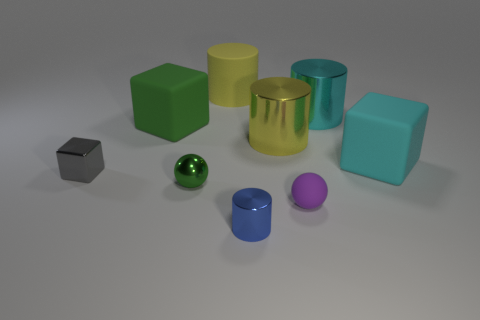There is a large matte object right of the small metal thing that is to the right of the metal sphere; what is its shape?
Provide a succinct answer. Cube. Does the tiny metallic cylinder have the same color as the small matte thing?
Your answer should be very brief. No. What number of spheres are either cyan objects or green things?
Your answer should be very brief. 1. The block that is both behind the small gray metal block and on the left side of the small blue cylinder is made of what material?
Keep it short and to the point. Rubber. How many large yellow things are behind the yellow metal cylinder?
Your answer should be compact. 1. Does the green object in front of the metal block have the same material as the yellow cylinder to the right of the yellow rubber thing?
Your answer should be compact. Yes. How many things are either big cyan things that are behind the green cube or gray metal blocks?
Offer a terse response. 2. Is the number of yellow shiny cylinders behind the cyan cylinder less than the number of cubes that are to the left of the big green thing?
Provide a short and direct response. Yes. How many other objects are the same size as the purple thing?
Give a very brief answer. 3. Is the material of the small green ball the same as the big cube to the left of the big cyan block?
Provide a succinct answer. No. 